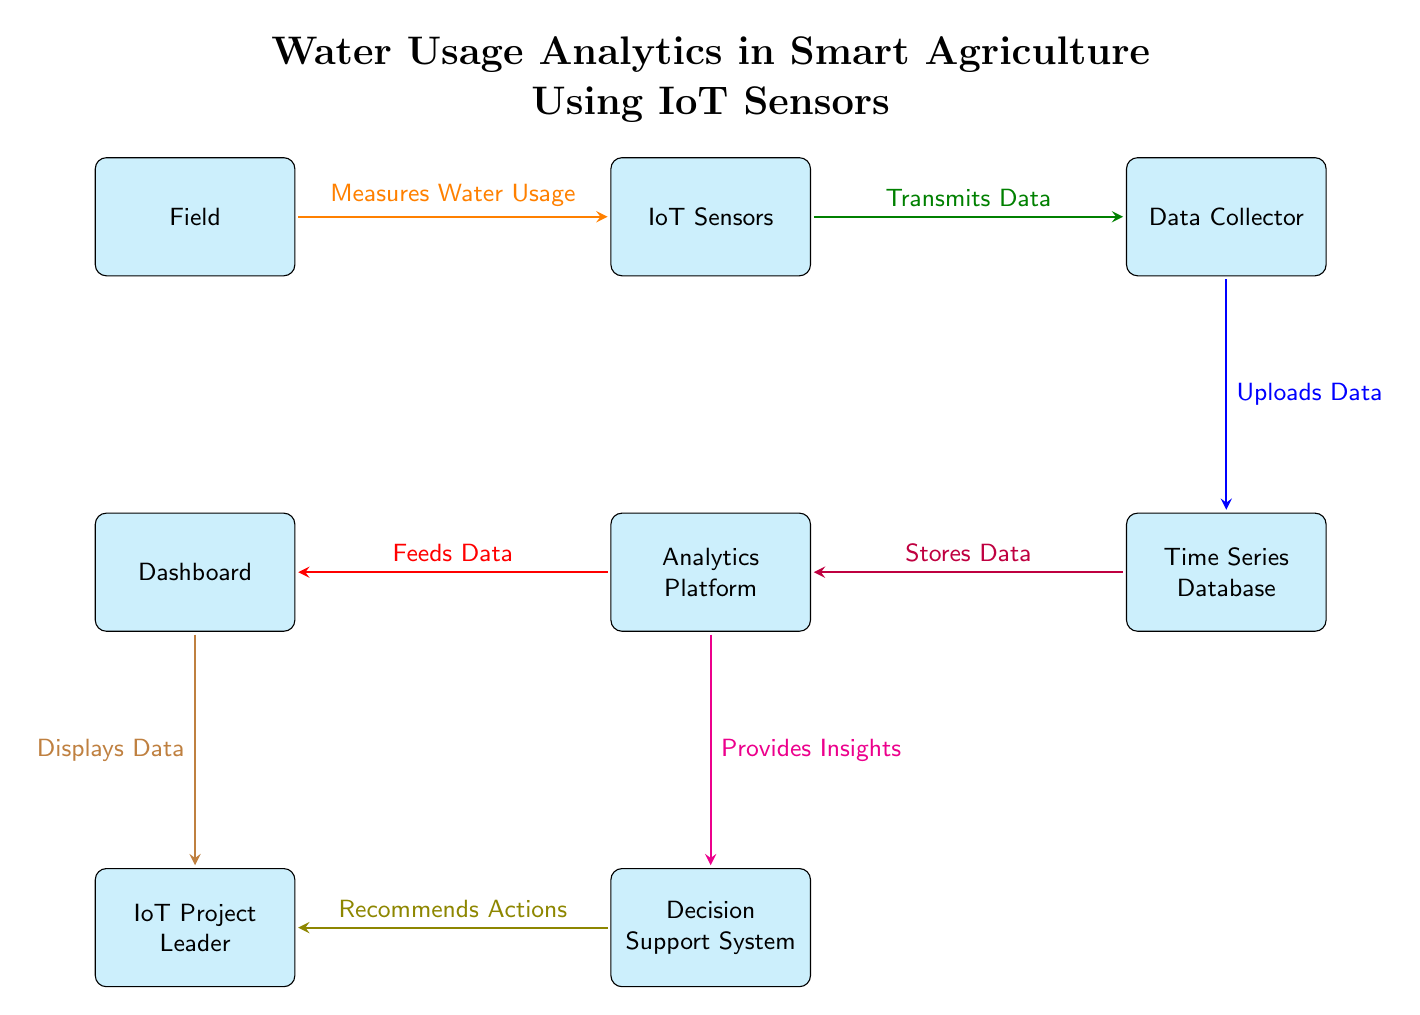What is the first entity in the flow? The diagram shows a flow starting from "Field," which is the first entity depicted on the left side of the diagram.
Answer: Field How many total entities are present in the diagram? By counting each of the labeled rectangles, we find a total of seven entities: Field, IoT Sensors, Data Collector, Time Series Database, Analytics Platform, Dashboard, and Decision Support System.
Answer: Seven What is the function of IoT Sensors? The arrow stemming from "Field" and pointing to "IoT Sensors" indicates that the IoT Sensors measure water usage, which is their primary function as depicted in the diagram.
Answer: Measures Water Usage Which entity does the Data Collector upload data to? The arrow pointing from "Data Collector" to "Time Series Database" shows that the Data Collector is responsible for uploading data specifically to the Time Series Database.
Answer: Time Series Database What is the relationship between the Analytics Platform and the Decision Support System? The arrow between the "Analytics Platform" and the "Decision Support System" indicates that the Analytics Platform provides insights to the Decision Support System, showing a direct supportive relationship between them.
Answer: Provides Insights What two entities does the Dashboard interact with? The diagram illustrates that the Dashboard interacts with both the Analytics Platform by receiving data from it and with the User by displaying data to them. Therefore, the two entities are Analytics Platform and User.
Answer: Analytics Platform and User How is data transmitted from IoT Sensors to the Data Collector? The arrow from "IoT Sensors" to "Data Collector" clearly states that data is transmitted from IoT Sensors to the Data Collector, which signifies an ongoing process of communication and data flow.
Answer: Transmits Data What type of system ultimately benefits from the recommendations provided? Following the flow, the arrow shows that the Decision Support System provides recommendations to the User, indicating that the User system ultimately benefits from these recommendations.
Answer: User 